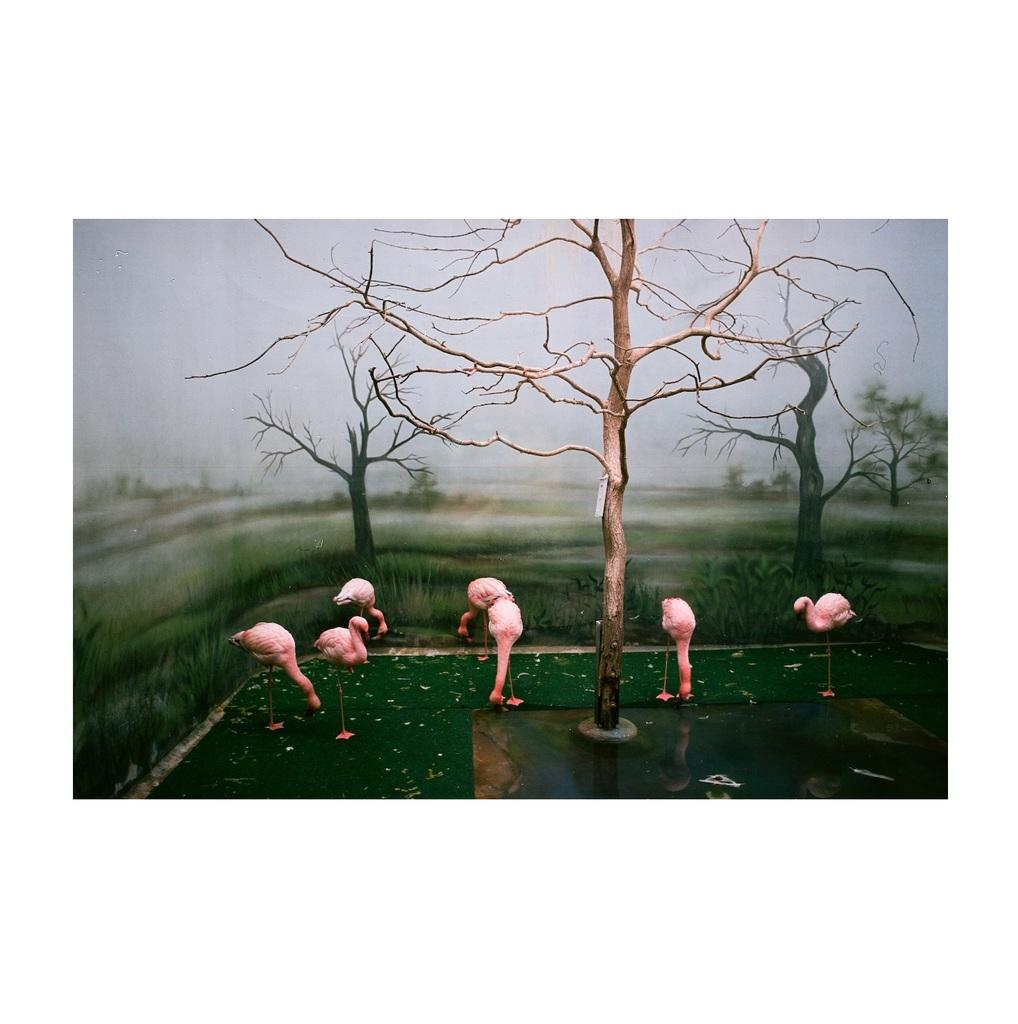What animals can be seen in the foreground of the picture? There are flamingos in the foreground of the picture. What type of vegetation is present in the foreground of the picture? There are trees and grass in the foreground of the picture. What is the terrain like in the foreground of the picture? There is water in the foreground of the picture. How would you describe the sky in the picture? The sky is cloudy in the picture. Can you describe the background of the image? The background of the image is blurred. How does the hen join the flamingos in the picture? There is no hen present in the picture, so it cannot join the flamingos. What type of fuel is used by the flamingos to fly in the picture? Flamingos do not use fuel to fly; they are powered by their own muscles and energy. 